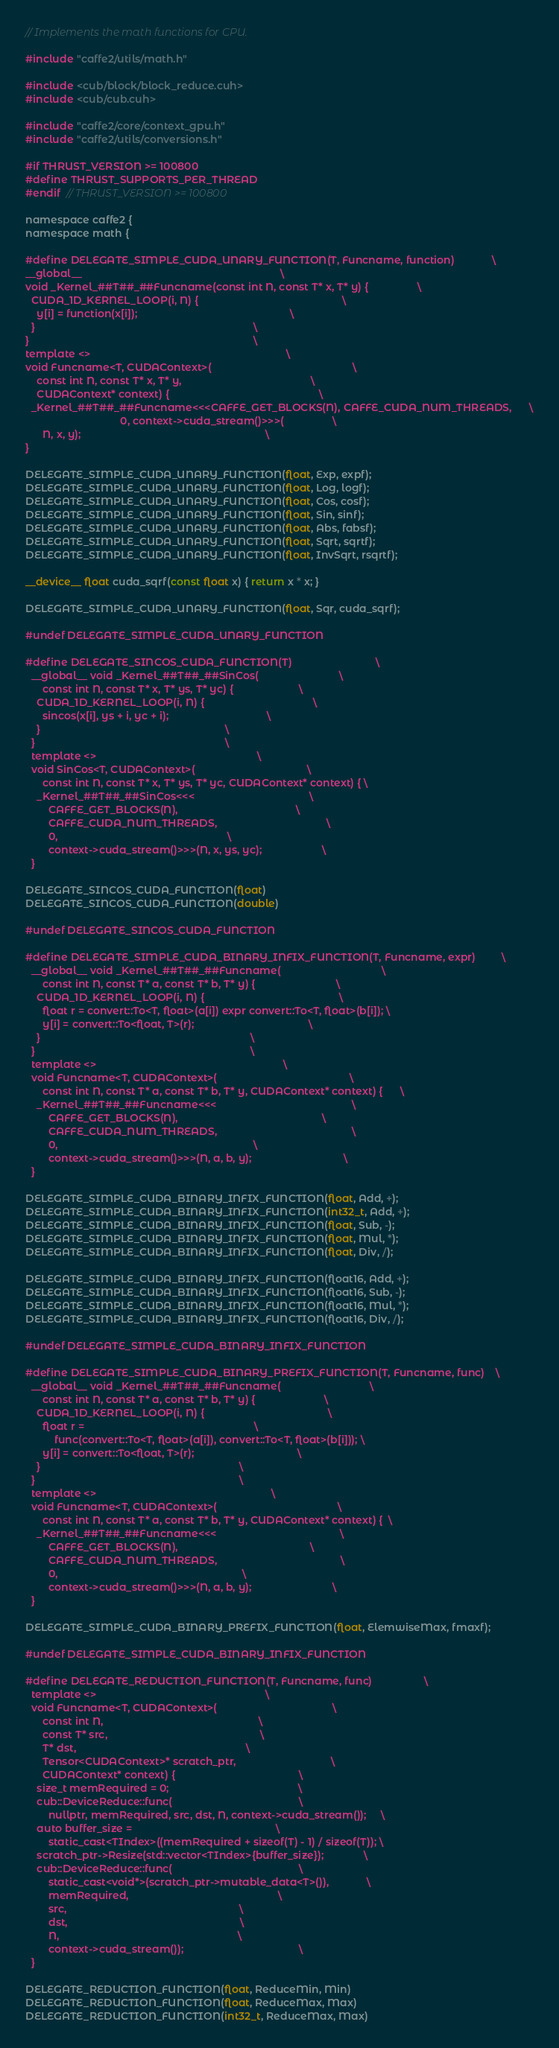Convert code to text. <code><loc_0><loc_0><loc_500><loc_500><_Cuda_>// Implements the math functions for CPU.

#include "caffe2/utils/math.h"

#include <cub/block/block_reduce.cuh>
#include <cub/cub.cuh>

#include "caffe2/core/context_gpu.h"
#include "caffe2/utils/conversions.h"

#if THRUST_VERSION >= 100800
#define THRUST_SUPPORTS_PER_THREAD
#endif  // THRUST_VERSION >= 100800

namespace caffe2 {
namespace math {

#define DELEGATE_SIMPLE_CUDA_UNARY_FUNCTION(T, Funcname, function)             \
__global__                                                                     \
void _Kernel_##T##_##Funcname(const int N, const T* x, T* y) {                 \
  CUDA_1D_KERNEL_LOOP(i, N) {                                                  \
    y[i] = function(x[i]);                                                     \
  }                                                                            \
}                                                                              \
template <>                                                                    \
void Funcname<T, CUDAContext>(                                                 \
    const int N, const T* x, T* y,                                             \
    CUDAContext* context) {                                                    \
  _Kernel_##T##_##Funcname<<<CAFFE_GET_BLOCKS(N), CAFFE_CUDA_NUM_THREADS,      \
                                 0, context->cuda_stream()>>>(                 \
      N, x, y);                                                                \
}

DELEGATE_SIMPLE_CUDA_UNARY_FUNCTION(float, Exp, expf);
DELEGATE_SIMPLE_CUDA_UNARY_FUNCTION(float, Log, logf);
DELEGATE_SIMPLE_CUDA_UNARY_FUNCTION(float, Cos, cosf);
DELEGATE_SIMPLE_CUDA_UNARY_FUNCTION(float, Sin, sinf);
DELEGATE_SIMPLE_CUDA_UNARY_FUNCTION(float, Abs, fabsf);
DELEGATE_SIMPLE_CUDA_UNARY_FUNCTION(float, Sqrt, sqrtf);
DELEGATE_SIMPLE_CUDA_UNARY_FUNCTION(float, InvSqrt, rsqrtf);

__device__ float cuda_sqrf(const float x) { return x * x; }

DELEGATE_SIMPLE_CUDA_UNARY_FUNCTION(float, Sqr, cuda_sqrf);

#undef DELEGATE_SIMPLE_CUDA_UNARY_FUNCTION

#define DELEGATE_SINCOS_CUDA_FUNCTION(T)                             \
  __global__ void _Kernel_##T##_##SinCos(                            \
      const int N, const T* x, T* ys, T* yc) {                       \
    CUDA_1D_KERNEL_LOOP(i, N) {                                      \
      sincos(x[i], ys + i, yc + i);                                  \
    }                                                                \
  }                                                                  \
  template <>                                                        \
  void SinCos<T, CUDAContext>(                                       \
      const int N, const T* x, T* ys, T* yc, CUDAContext* context) { \
    _Kernel_##T##_##SinCos<<<                                        \
        CAFFE_GET_BLOCKS(N),                                         \
        CAFFE_CUDA_NUM_THREADS,                                      \
        0,                                                           \
        context->cuda_stream()>>>(N, x, ys, yc);                     \
  }

DELEGATE_SINCOS_CUDA_FUNCTION(float)
DELEGATE_SINCOS_CUDA_FUNCTION(double)

#undef DELEGATE_SINCOS_CUDA_FUNCTION

#define DELEGATE_SIMPLE_CUDA_BINARY_INFIX_FUNCTION(T, Funcname, expr)         \
  __global__ void _Kernel_##T##_##Funcname(                                   \
      const int N, const T* a, const T* b, T* y) {                            \
    CUDA_1D_KERNEL_LOOP(i, N) {                                               \
      float r = convert::To<T, float>(a[i]) expr convert::To<T, float>(b[i]); \
      y[i] = convert::To<float, T>(r);                                        \
    }                                                                         \
  }                                                                           \
  template <>                                                                 \
  void Funcname<T, CUDAContext>(                                              \
      const int N, const T* a, const T* b, T* y, CUDAContext* context) {      \
    _Kernel_##T##_##Funcname<<<                                               \
        CAFFE_GET_BLOCKS(N),                                                  \
        CAFFE_CUDA_NUM_THREADS,                                               \
        0,                                                                    \
        context->cuda_stream()>>>(N, a, b, y);                                \
  }

DELEGATE_SIMPLE_CUDA_BINARY_INFIX_FUNCTION(float, Add, +);
DELEGATE_SIMPLE_CUDA_BINARY_INFIX_FUNCTION(int32_t, Add, +);
DELEGATE_SIMPLE_CUDA_BINARY_INFIX_FUNCTION(float, Sub, -);
DELEGATE_SIMPLE_CUDA_BINARY_INFIX_FUNCTION(float, Mul, *);
DELEGATE_SIMPLE_CUDA_BINARY_INFIX_FUNCTION(float, Div, /);

DELEGATE_SIMPLE_CUDA_BINARY_INFIX_FUNCTION(float16, Add, +);
DELEGATE_SIMPLE_CUDA_BINARY_INFIX_FUNCTION(float16, Sub, -);
DELEGATE_SIMPLE_CUDA_BINARY_INFIX_FUNCTION(float16, Mul, *);
DELEGATE_SIMPLE_CUDA_BINARY_INFIX_FUNCTION(float16, Div, /);

#undef DELEGATE_SIMPLE_CUDA_BINARY_INFIX_FUNCTION

#define DELEGATE_SIMPLE_CUDA_BINARY_PREFIX_FUNCTION(T, Funcname, func)    \
  __global__ void _Kernel_##T##_##Funcname(                               \
      const int N, const T* a, const T* b, T* y) {                        \
    CUDA_1D_KERNEL_LOOP(i, N) {                                           \
      float r =                                                           \
          func(convert::To<T, float>(a[i]), convert::To<T, float>(b[i])); \
      y[i] = convert::To<float, T>(r);                                    \
    }                                                                     \
  }                                                                       \
  template <>                                                             \
  void Funcname<T, CUDAContext>(                                          \
      const int N, const T* a, const T* b, T* y, CUDAContext* context) {  \
    _Kernel_##T##_##Funcname<<<                                           \
        CAFFE_GET_BLOCKS(N),                                              \
        CAFFE_CUDA_NUM_THREADS,                                           \
        0,                                                                \
        context->cuda_stream()>>>(N, a, b, y);                            \
  }

DELEGATE_SIMPLE_CUDA_BINARY_PREFIX_FUNCTION(float, ElemwiseMax, fmaxf);

#undef DELEGATE_SIMPLE_CUDA_BINARY_INFIX_FUNCTION

#define DELEGATE_REDUCTION_FUNCTION(T, Funcname, func)                  \
  template <>                                                           \
  void Funcname<T, CUDAContext>(                                        \
      const int N,                                                      \
      const T* src,                                                     \
      T* dst,                                                           \
      Tensor<CUDAContext>* scratch_ptr,                                 \
      CUDAContext* context) {                                           \
    size_t memRequired = 0;                                             \
    cub::DeviceReduce::func(                                            \
        nullptr, memRequired, src, dst, N, context->cuda_stream());     \
    auto buffer_size =                                                  \
        static_cast<TIndex>((memRequired + sizeof(T) - 1) / sizeof(T)); \
    scratch_ptr->Resize(std::vector<TIndex>{buffer_size});              \
    cub::DeviceReduce::func(                                            \
        static_cast<void*>(scratch_ptr->mutable_data<T>()),             \
        memRequired,                                                    \
        src,                                                            \
        dst,                                                            \
        N,                                                              \
        context->cuda_stream());                                        \
  }

DELEGATE_REDUCTION_FUNCTION(float, ReduceMin, Min)
DELEGATE_REDUCTION_FUNCTION(float, ReduceMax, Max)
DELEGATE_REDUCTION_FUNCTION(int32_t, ReduceMax, Max)</code> 